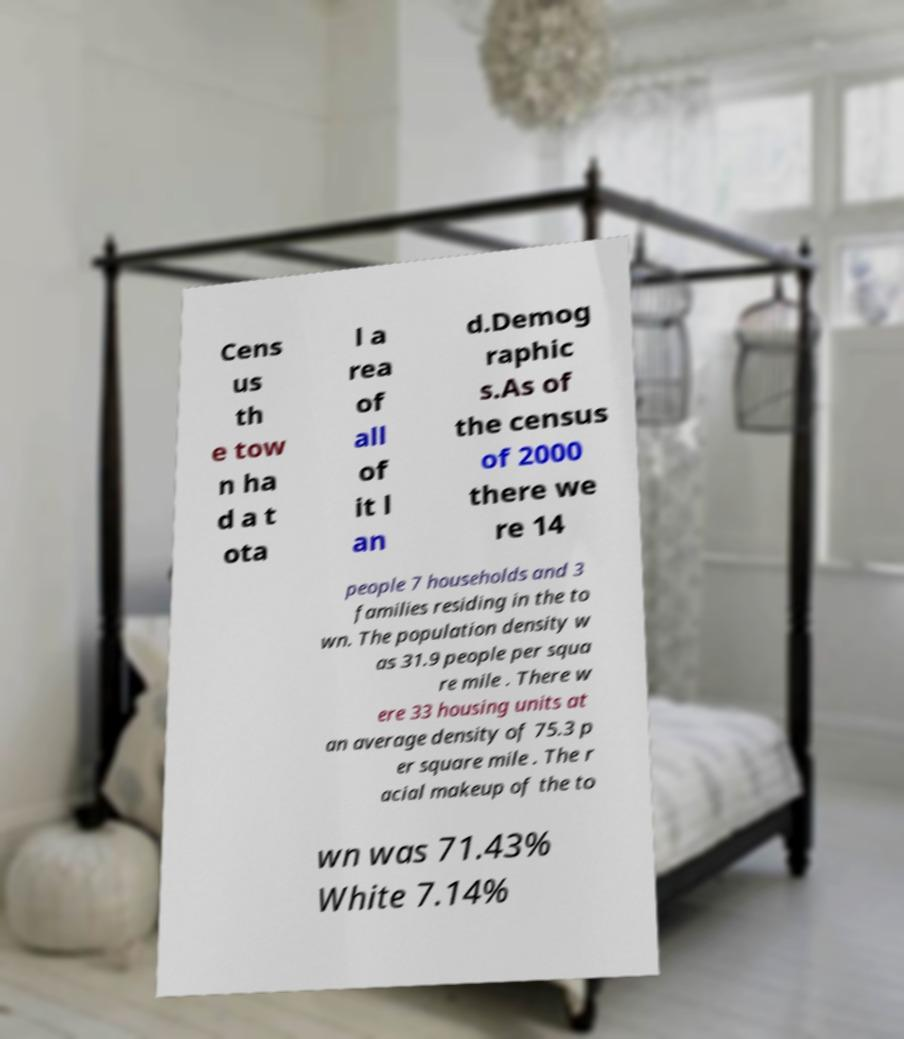What messages or text are displayed in this image? I need them in a readable, typed format. Cens us th e tow n ha d a t ota l a rea of all of it l an d.Demog raphic s.As of the census of 2000 there we re 14 people 7 households and 3 families residing in the to wn. The population density w as 31.9 people per squa re mile . There w ere 33 housing units at an average density of 75.3 p er square mile . The r acial makeup of the to wn was 71.43% White 7.14% 